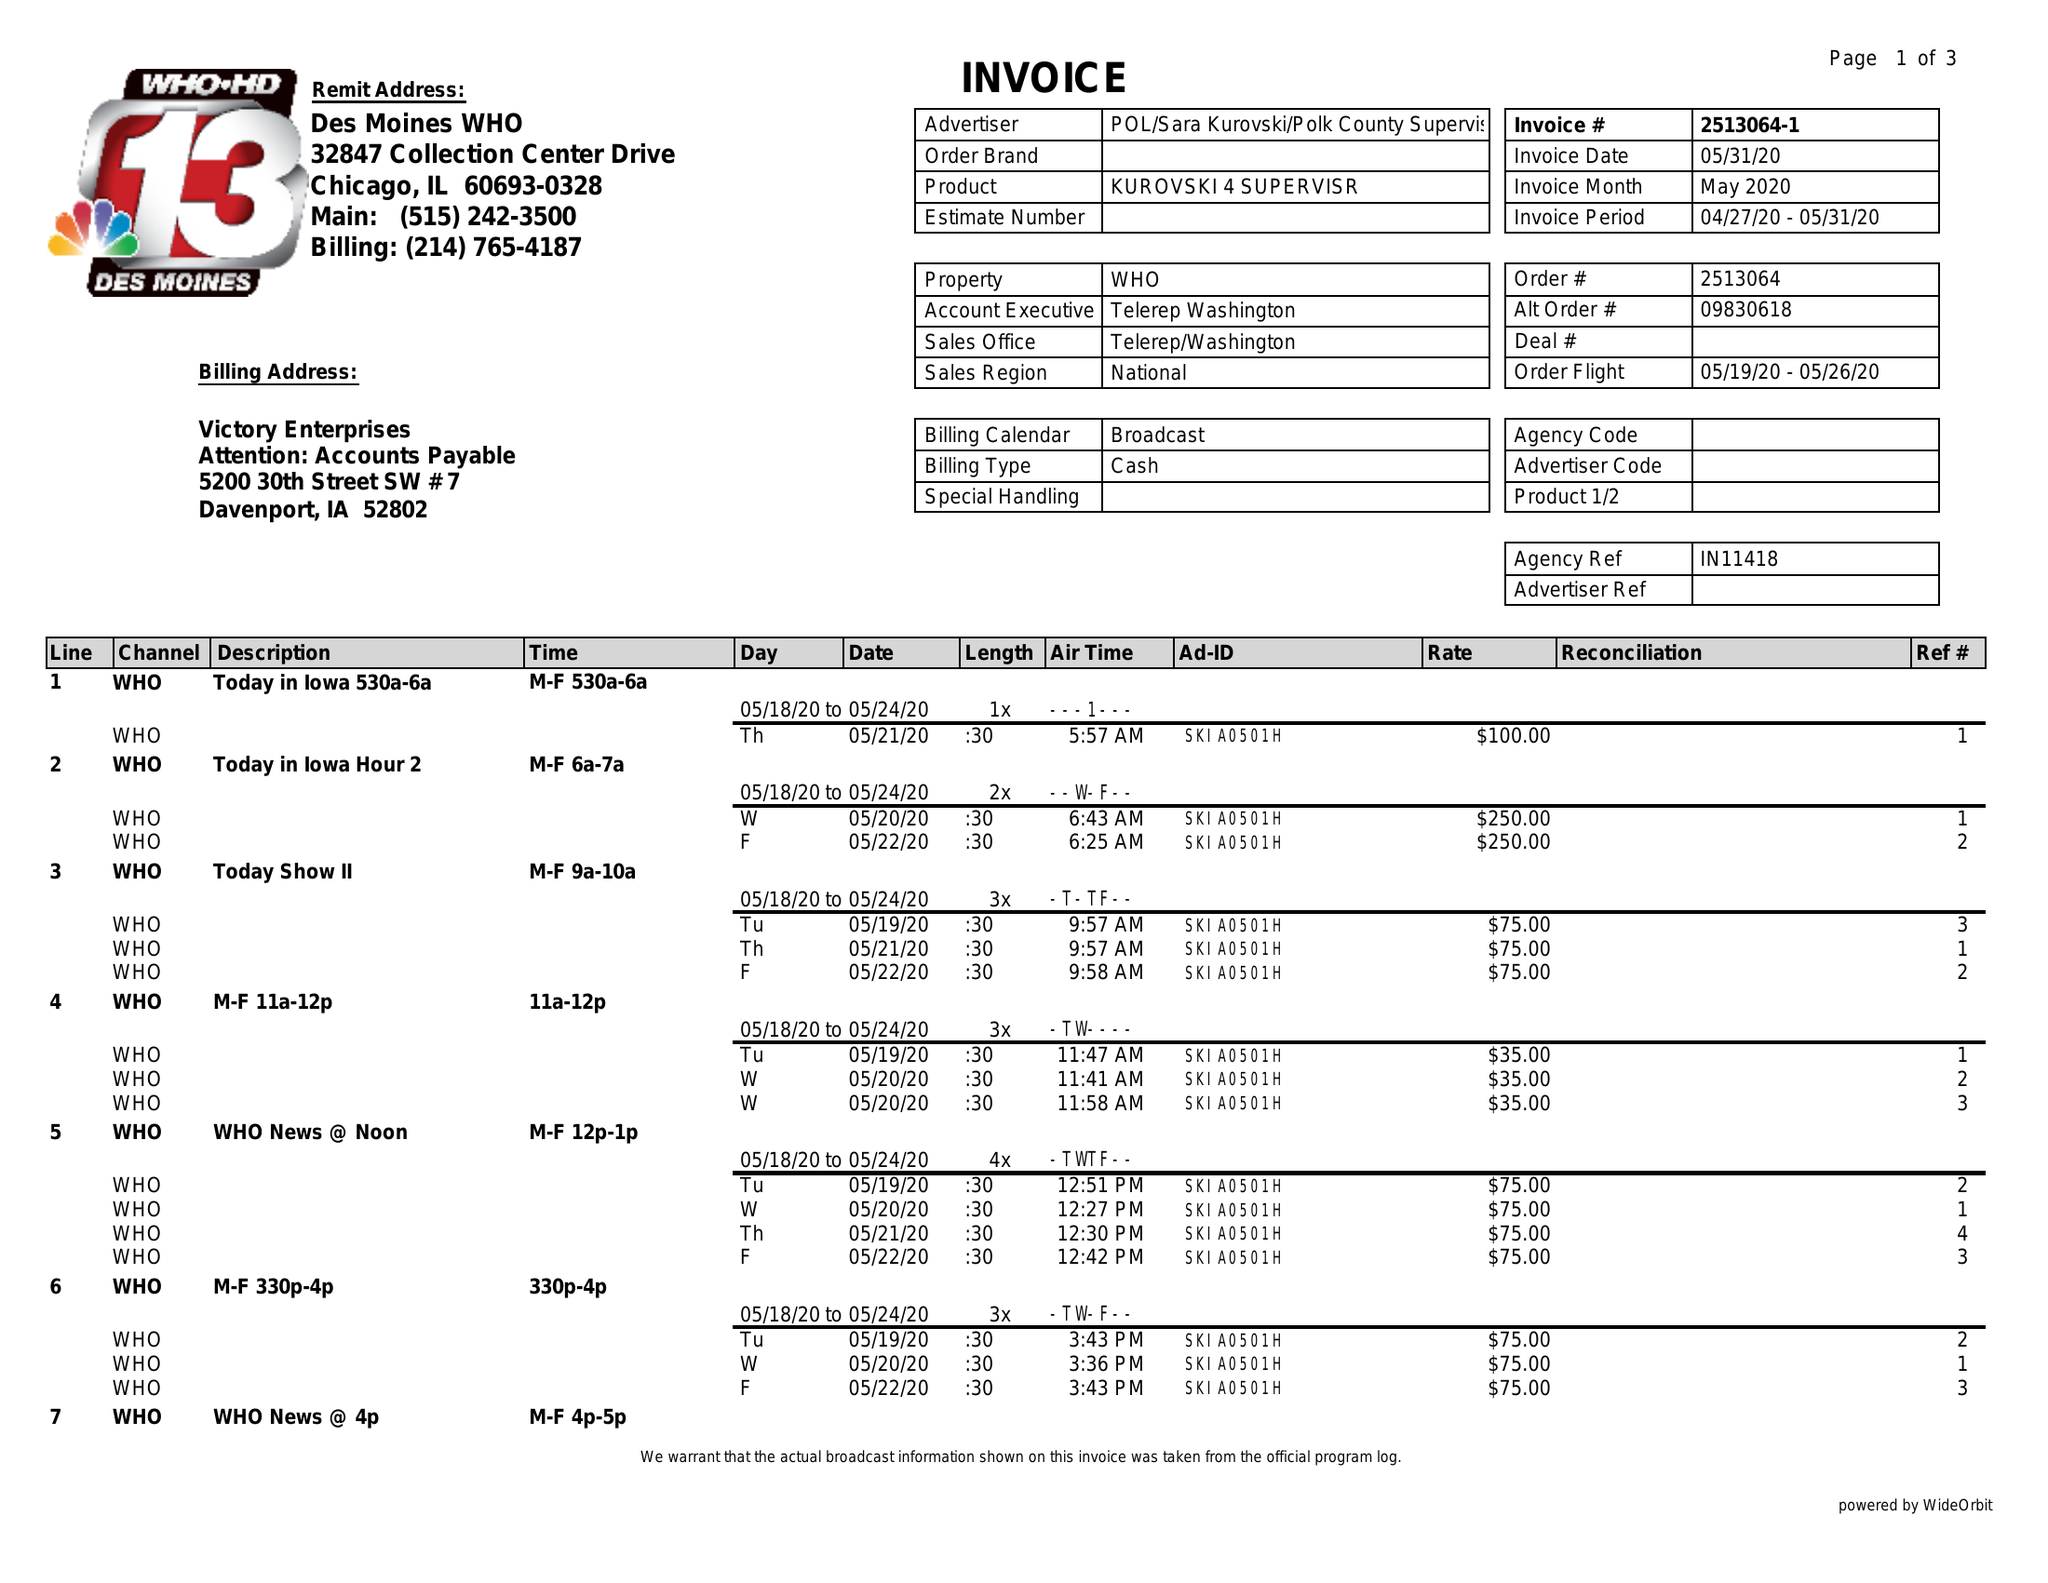What is the value for the gross_amount?
Answer the question using a single word or phrase. 6300.00 